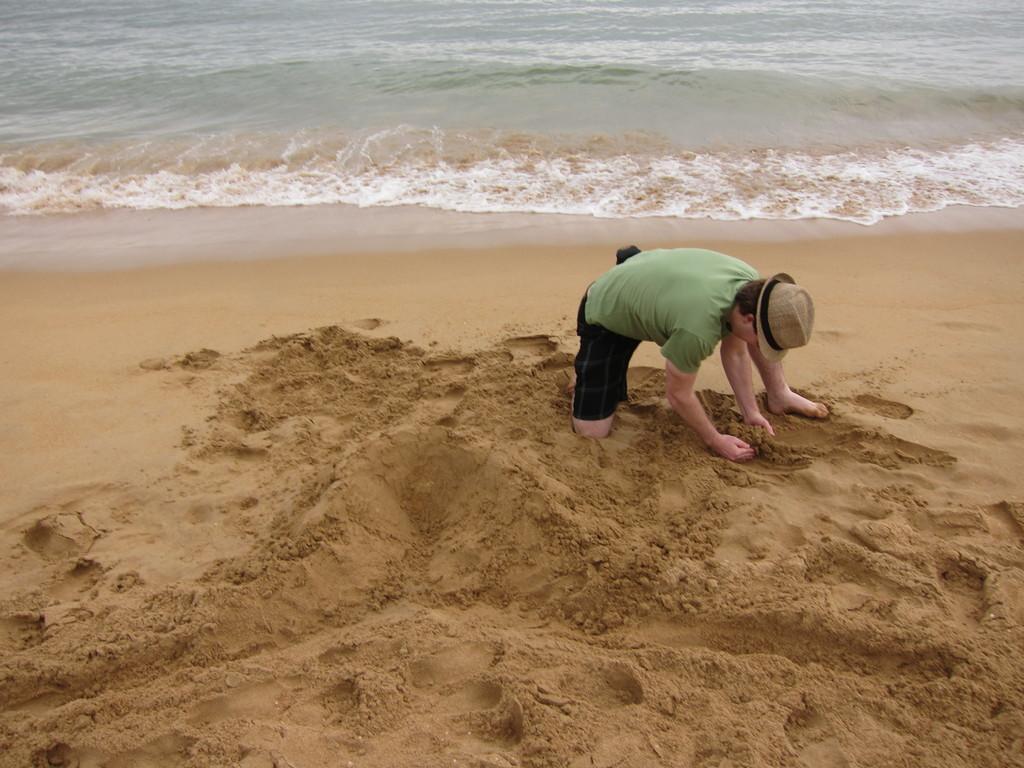Can you describe this image briefly? This picture is clicked outside the city. In the foreground we can see the mud and there is a person wearing hat and squatting on the ground. In the background we can see a water body and a shore line. 